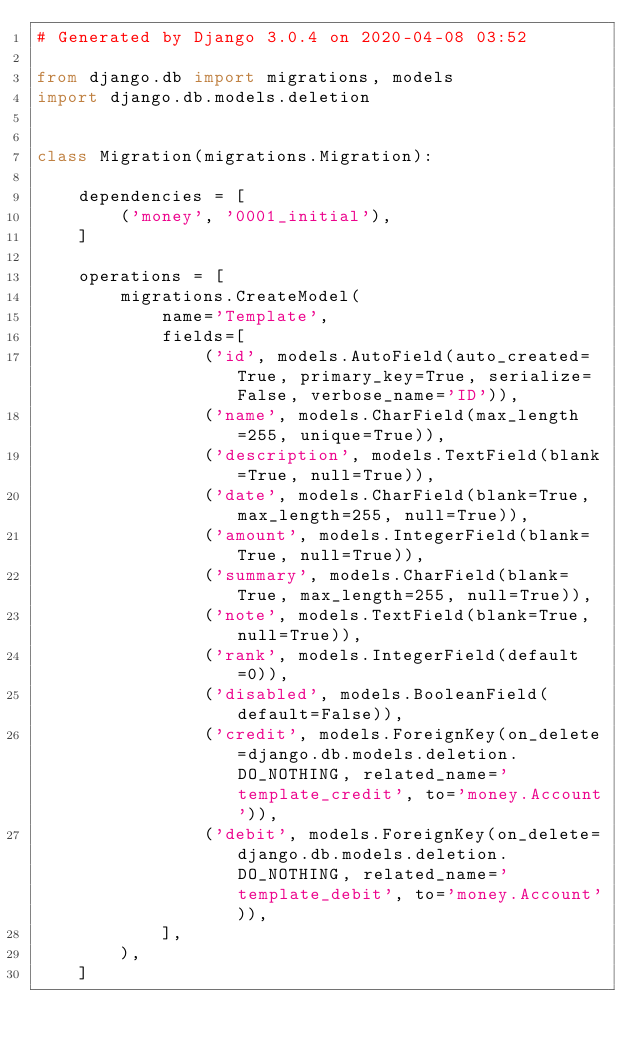<code> <loc_0><loc_0><loc_500><loc_500><_Python_># Generated by Django 3.0.4 on 2020-04-08 03:52

from django.db import migrations, models
import django.db.models.deletion


class Migration(migrations.Migration):

    dependencies = [
        ('money', '0001_initial'),
    ]

    operations = [
        migrations.CreateModel(
            name='Template',
            fields=[
                ('id', models.AutoField(auto_created=True, primary_key=True, serialize=False, verbose_name='ID')),
                ('name', models.CharField(max_length=255, unique=True)),
                ('description', models.TextField(blank=True, null=True)),
                ('date', models.CharField(blank=True, max_length=255, null=True)),
                ('amount', models.IntegerField(blank=True, null=True)),
                ('summary', models.CharField(blank=True, max_length=255, null=True)),
                ('note', models.TextField(blank=True, null=True)),
                ('rank', models.IntegerField(default=0)),
                ('disabled', models.BooleanField(default=False)),
                ('credit', models.ForeignKey(on_delete=django.db.models.deletion.DO_NOTHING, related_name='template_credit', to='money.Account')),
                ('debit', models.ForeignKey(on_delete=django.db.models.deletion.DO_NOTHING, related_name='template_debit', to='money.Account')),
            ],
        ),
    ]
</code> 